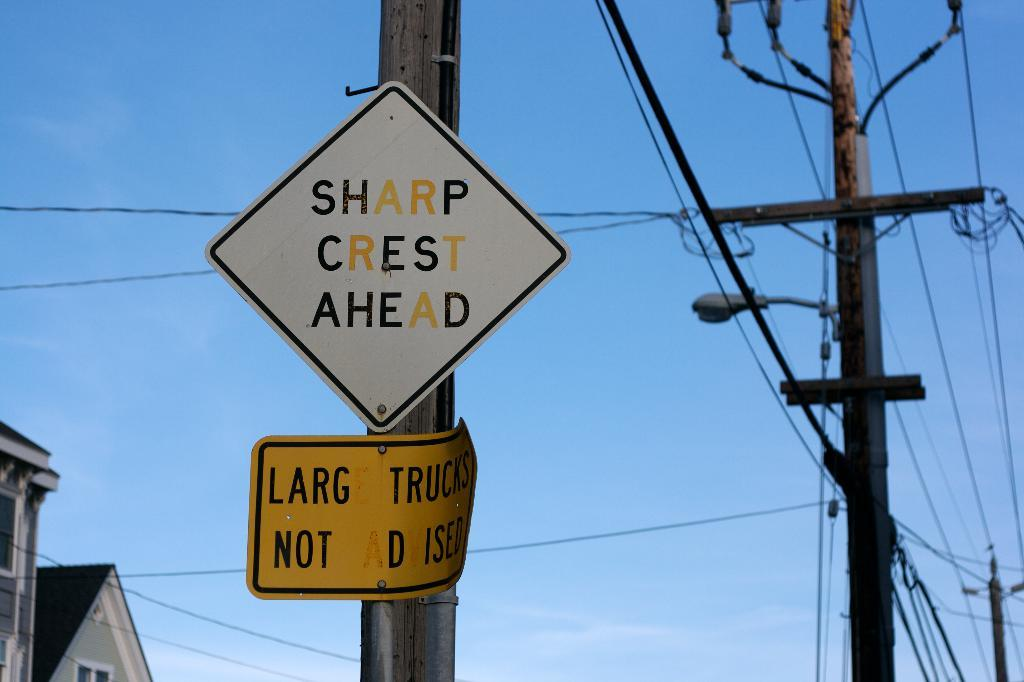<image>
Describe the image concisely. a sign that says there is a sharp crest ahead 